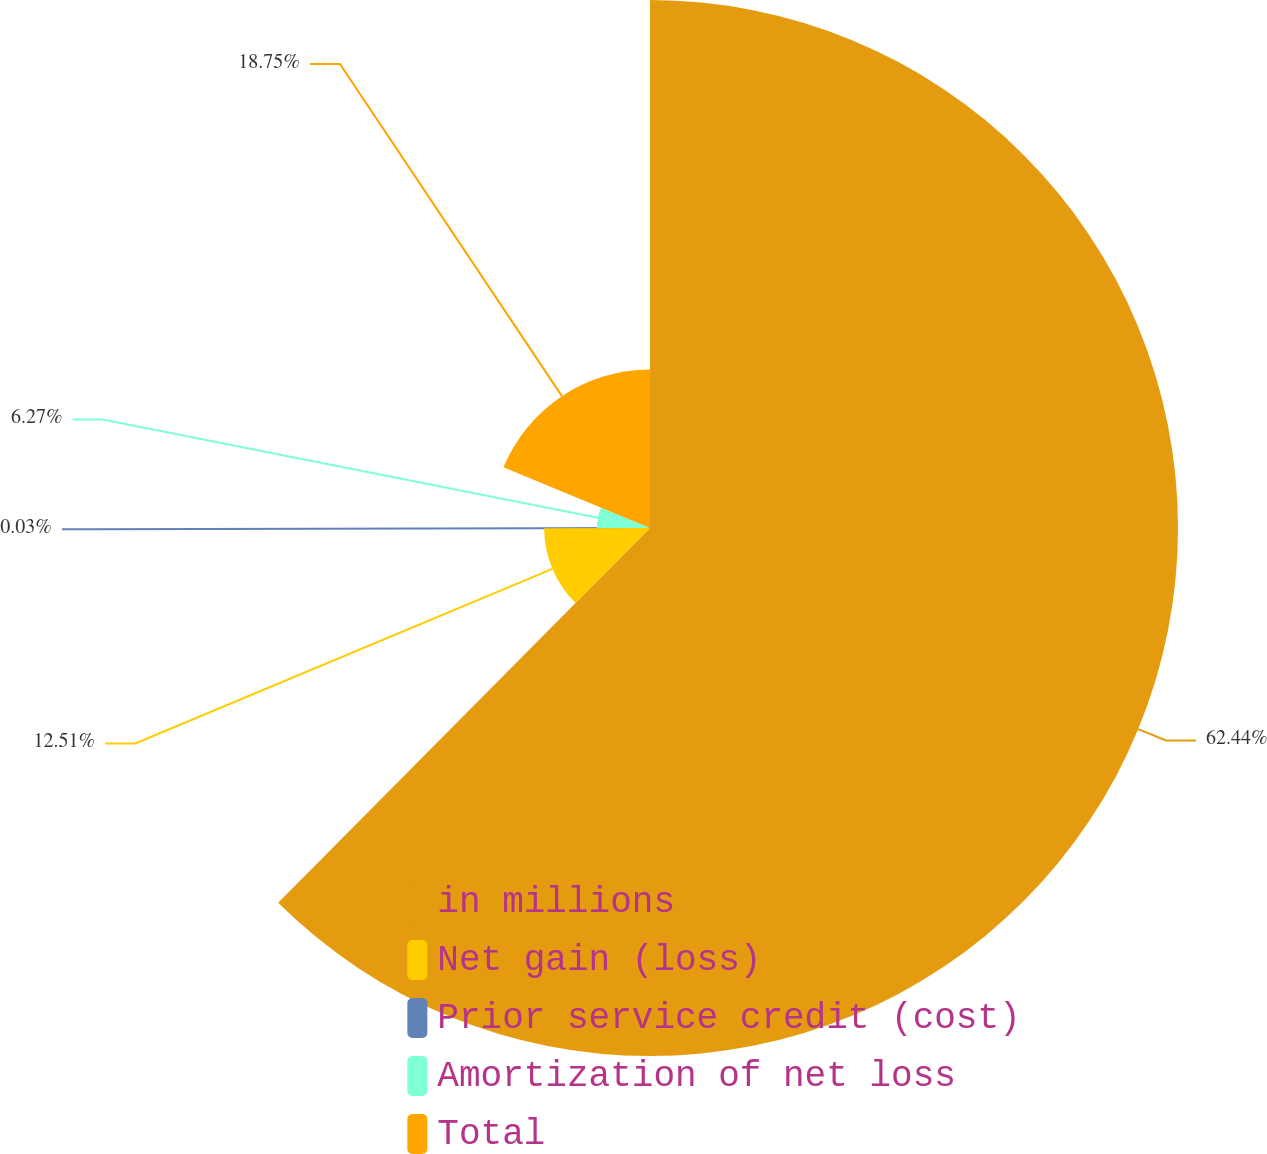Convert chart to OTSL. <chart><loc_0><loc_0><loc_500><loc_500><pie_chart><fcel>in millions<fcel>Net gain (loss)<fcel>Prior service credit (cost)<fcel>Amortization of net loss<fcel>Total<nl><fcel>62.43%<fcel>12.51%<fcel>0.03%<fcel>6.27%<fcel>18.75%<nl></chart> 